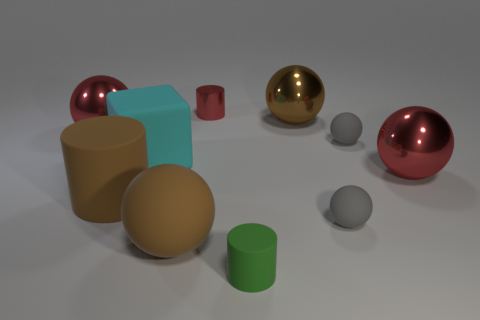There is another large sphere that is the same color as the big matte sphere; what is its material?
Ensure brevity in your answer.  Metal. There is a big metallic sphere left of the red cylinder; does it have the same color as the small cylinder behind the large brown metal sphere?
Provide a succinct answer. Yes. Do the big cylinder that is in front of the big block and the small red cylinder have the same material?
Your answer should be compact. No. Is the number of big brown things that are to the right of the green matte cylinder the same as the number of big cyan blocks in front of the large brown rubber sphere?
Provide a succinct answer. No. There is a thing that is behind the cyan cube and on the left side of the cyan rubber object; what is its shape?
Keep it short and to the point. Sphere. How many large matte objects are behind the big brown rubber sphere?
Your answer should be compact. 2. What number of other objects are there of the same shape as the small green object?
Keep it short and to the point. 2. Are there fewer big red things than objects?
Provide a short and direct response. Yes. There is a cylinder that is both in front of the small red metallic thing and behind the small green cylinder; how big is it?
Your answer should be compact. Large. There is a red metallic thing behind the big thing behind the red metal thing left of the tiny red object; what is its size?
Keep it short and to the point. Small. 